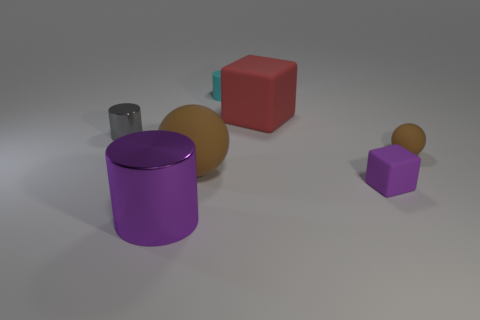Are there more big gray rubber cubes than big rubber spheres?
Make the answer very short. No. What is the thing that is both left of the big red matte block and behind the tiny gray object made of?
Ensure brevity in your answer.  Rubber. How many other things are made of the same material as the big red thing?
Give a very brief answer. 4. How many rubber cubes have the same color as the large metal thing?
Your response must be concise. 1. There is a brown sphere that is right of the large rubber object behind the brown thing on the right side of the tiny matte cylinder; what size is it?
Make the answer very short. Small. What number of shiny objects are either big blocks or small balls?
Provide a short and direct response. 0. Is the shape of the cyan matte object the same as the shiny thing behind the large shiny cylinder?
Your answer should be very brief. Yes. Are there more purple cubes behind the small brown matte ball than objects that are on the left side of the purple metallic cylinder?
Your answer should be very brief. No. Is there any other thing that is the same color as the big shiny cylinder?
Offer a terse response. Yes. There is a metallic cylinder that is behind the brown sphere on the right side of the large sphere; is there a cyan cylinder that is in front of it?
Your response must be concise. No. 